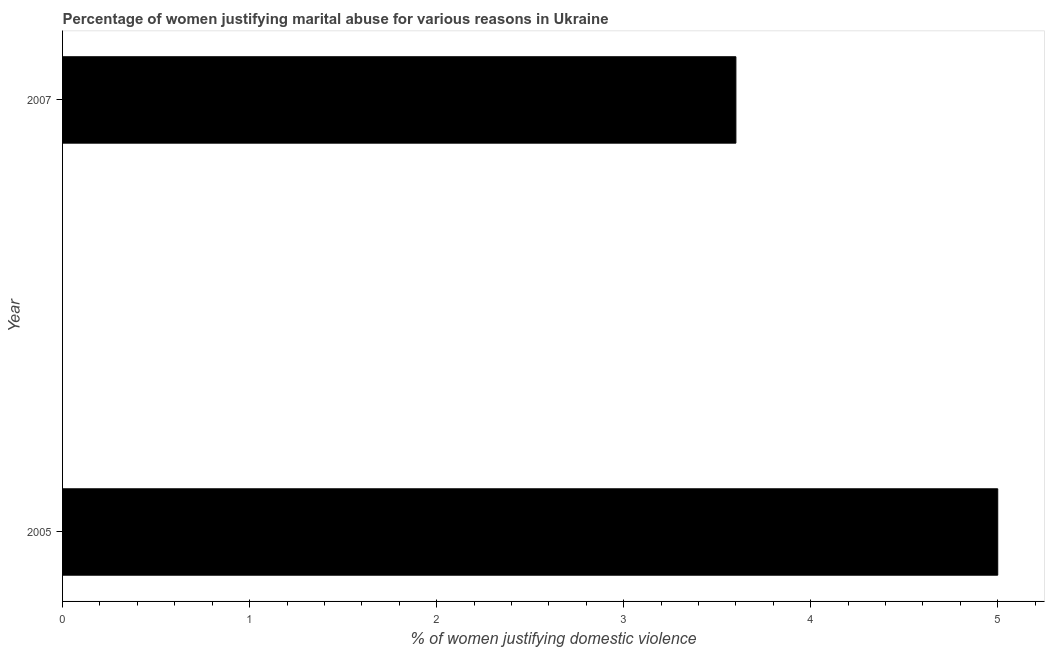Does the graph contain grids?
Ensure brevity in your answer.  No. What is the title of the graph?
Provide a succinct answer. Percentage of women justifying marital abuse for various reasons in Ukraine. What is the label or title of the X-axis?
Keep it short and to the point. % of women justifying domestic violence. What is the label or title of the Y-axis?
Your answer should be compact. Year. Across all years, what is the minimum percentage of women justifying marital abuse?
Give a very brief answer. 3.6. In which year was the percentage of women justifying marital abuse maximum?
Give a very brief answer. 2005. What is the average percentage of women justifying marital abuse per year?
Your response must be concise. 4.3. What is the median percentage of women justifying marital abuse?
Offer a very short reply. 4.3. What is the ratio of the percentage of women justifying marital abuse in 2005 to that in 2007?
Provide a succinct answer. 1.39. Is the percentage of women justifying marital abuse in 2005 less than that in 2007?
Ensure brevity in your answer.  No. How many bars are there?
Provide a short and direct response. 2. Are all the bars in the graph horizontal?
Your response must be concise. Yes. What is the difference between two consecutive major ticks on the X-axis?
Your answer should be very brief. 1. What is the % of women justifying domestic violence in 2007?
Offer a very short reply. 3.6. What is the ratio of the % of women justifying domestic violence in 2005 to that in 2007?
Offer a very short reply. 1.39. 